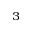<formula> <loc_0><loc_0><loc_500><loc_500>^ { 3 }</formula> 